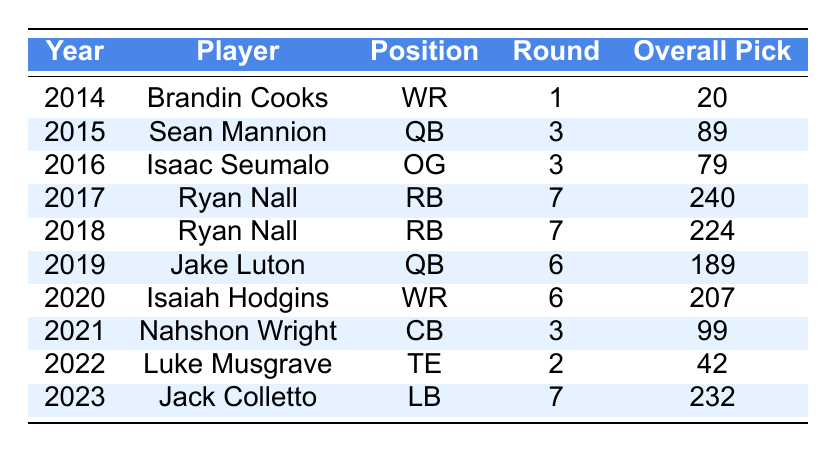What year did Brandin Cooks get drafted? The table shows that Brandin Cooks was drafted in 2014.
Answer: 2014 Which player was selected as a QB in 2015? The table indicates that Sean Mannion was drafted as a QB in 2015.
Answer: Sean Mannion How many players were drafted in the 7th round? From the table, Ryan Nall is listed as a 7th round pick in 2017 (overall pick 240) and again in 2018 (overall pick 224) and Jack Colletto is listed in 2023 (overall pick 232), making a total of 3 players in the 7th round.
Answer: 3 Which player was drafted first overall among the picks listed? The overall picks show that Brandin Cooks was selected at pick 20 in 2014, which is the highest (earliest) pick compared to the others in the table.
Answer: Brandin Cooks What is the average round of the players drafted? The rounds for each player are 1, 3, 3, 7, 7, 6, 6, 3, 2, and 7. Adding these up gives 1 + 3 + 3 + 7 + 7 + 6 + 6 + 3 + 2 + 7 = 45. There are 10 players, so the average is 45/10 = 4.5.
Answer: 4.5 Did any player get drafted in the 2nd round? Luke Musgrave was drafted in 2022 as a TE, and his pick was in the 2nd round according to the table.
Answer: Yes Who were the two RBs drafted and in what years? The table lists Ryan Nall drafted as a RB in both 2017 and 2018.
Answer: Ryan Nall in 2017 and 2018 What is the overall pick of the highest-drafted WR? The table shows that Brandin Cooks, drafted in 2014, was selected at the overall pick of 20, which is the highest among the WRs listed.
Answer: 20 How many years are represented in the table? There are drafts listed from 2014 to 2023, which is a total of 10 years.
Answer: 10 years Which position has the most players drafted? The table shows that both RB and QB have 2 players drafted each (Ryan Nall as RB twice and 2 QBs: Sean Mannion and Jake Luton). Since there are more RBs, there is a tie with QBs.
Answer: RB and QB (each has 2 players) 